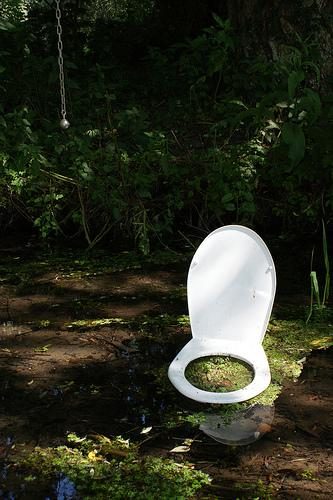Question: where is this scene?
Choices:
A. Farm.
B. Forest.
C. Field.
D. Lake.
Answer with the letter. Answer: B 